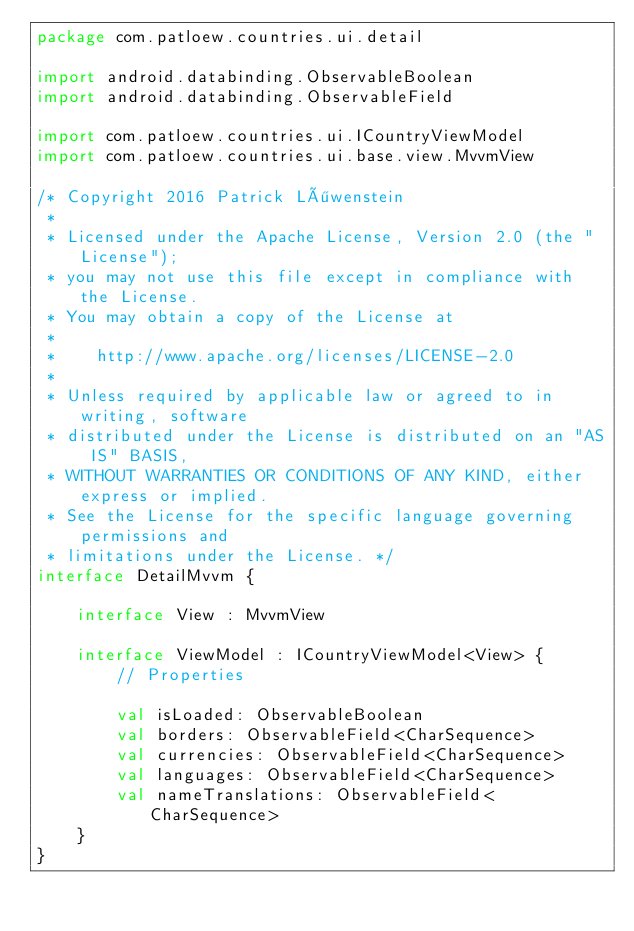Convert code to text. <code><loc_0><loc_0><loc_500><loc_500><_Kotlin_>package com.patloew.countries.ui.detail

import android.databinding.ObservableBoolean
import android.databinding.ObservableField

import com.patloew.countries.ui.ICountryViewModel
import com.patloew.countries.ui.base.view.MvvmView

/* Copyright 2016 Patrick Löwenstein
 *
 * Licensed under the Apache License, Version 2.0 (the "License");
 * you may not use this file except in compliance with the License.
 * You may obtain a copy of the License at
 *
 *    http://www.apache.org/licenses/LICENSE-2.0
 *
 * Unless required by applicable law or agreed to in writing, software
 * distributed under the License is distributed on an "AS IS" BASIS,
 * WITHOUT WARRANTIES OR CONDITIONS OF ANY KIND, either express or implied.
 * See the License for the specific language governing permissions and
 * limitations under the License. */
interface DetailMvvm {

    interface View : MvvmView

    interface ViewModel : ICountryViewModel<View> {
        // Properties

        val isLoaded: ObservableBoolean
        val borders: ObservableField<CharSequence>
        val currencies: ObservableField<CharSequence>
        val languages: ObservableField<CharSequence>
        val nameTranslations: ObservableField<CharSequence>
    }
}
</code> 